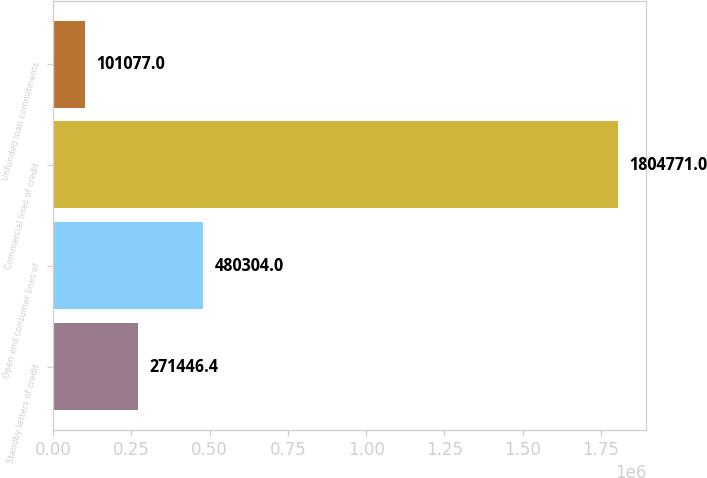Convert chart. <chart><loc_0><loc_0><loc_500><loc_500><bar_chart><fcel>Standby letters of credit<fcel>Open end consumer lines of<fcel>Commercial lines of credit<fcel>Unfunded loan commitments<nl><fcel>271446<fcel>480304<fcel>1.80477e+06<fcel>101077<nl></chart> 